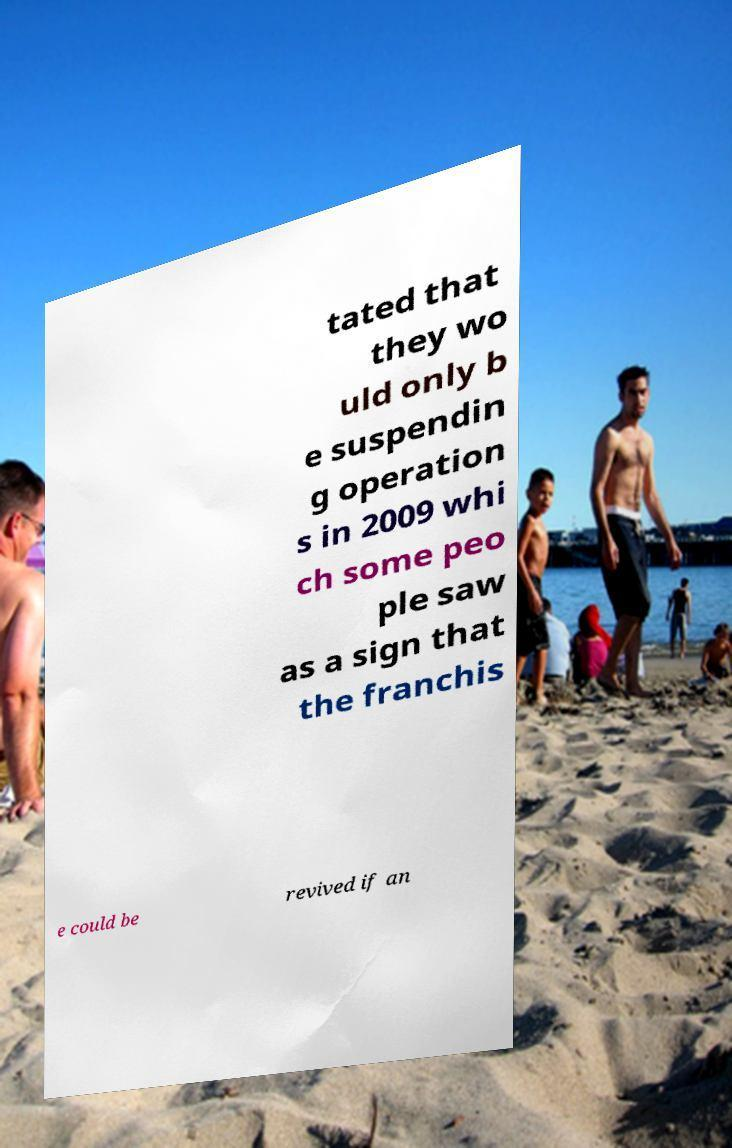Please read and relay the text visible in this image. What does it say? tated that they wo uld only b e suspendin g operation s in 2009 whi ch some peo ple saw as a sign that the franchis e could be revived if an 